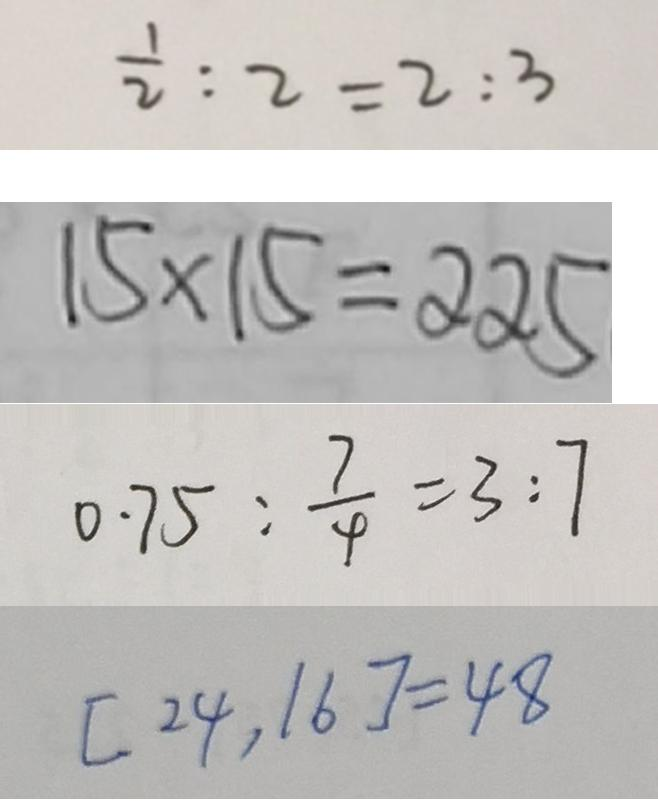<formula> <loc_0><loc_0><loc_500><loc_500>\frac { 1 } { 2 } : 2 = 2 : 3 
 1 5 \times 1 5 = 2 2 5 
 0 . 7 5 : \frac { 7 } { 4 } = 3 : 7 
 [ 2 4 , 1 6 ] = 4 8</formula> 